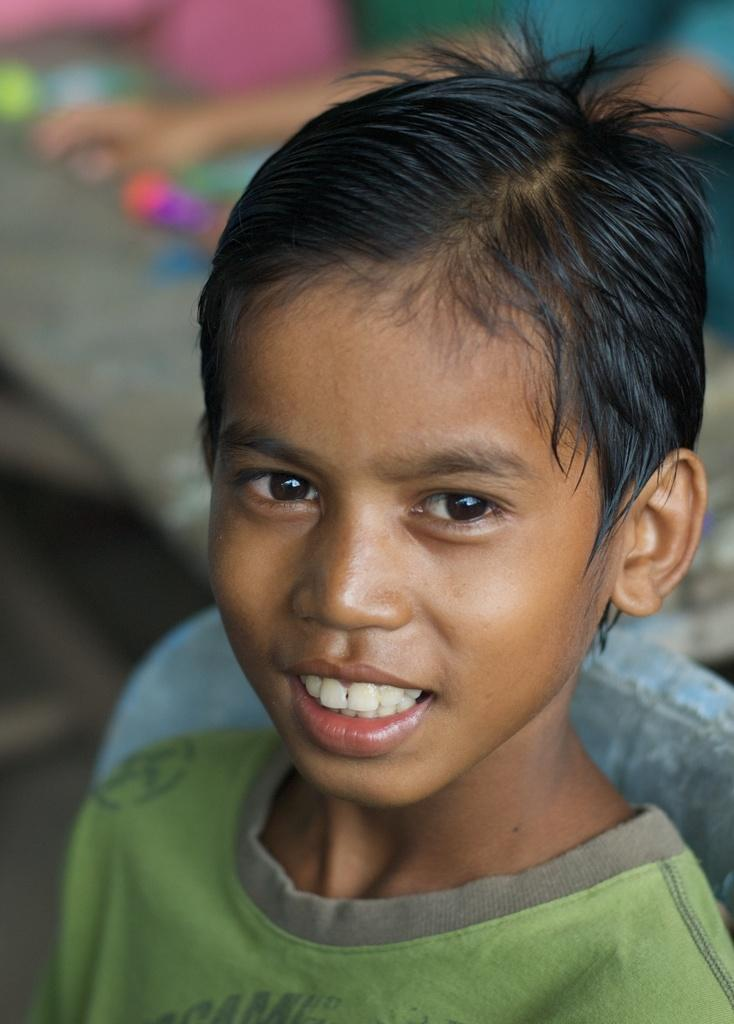What is the main subject of the image? The main subject of the image is a kid. What is the kid doing in the image? The kid is standing and smiling. What is the kid wearing in the image? The kid is wearing a green color shirt. Can you describe the background of the image? The background of the image is blurry. What type of meat is the kid holding in the image? There is no meat present in the image; the kid is not holding any food item. 